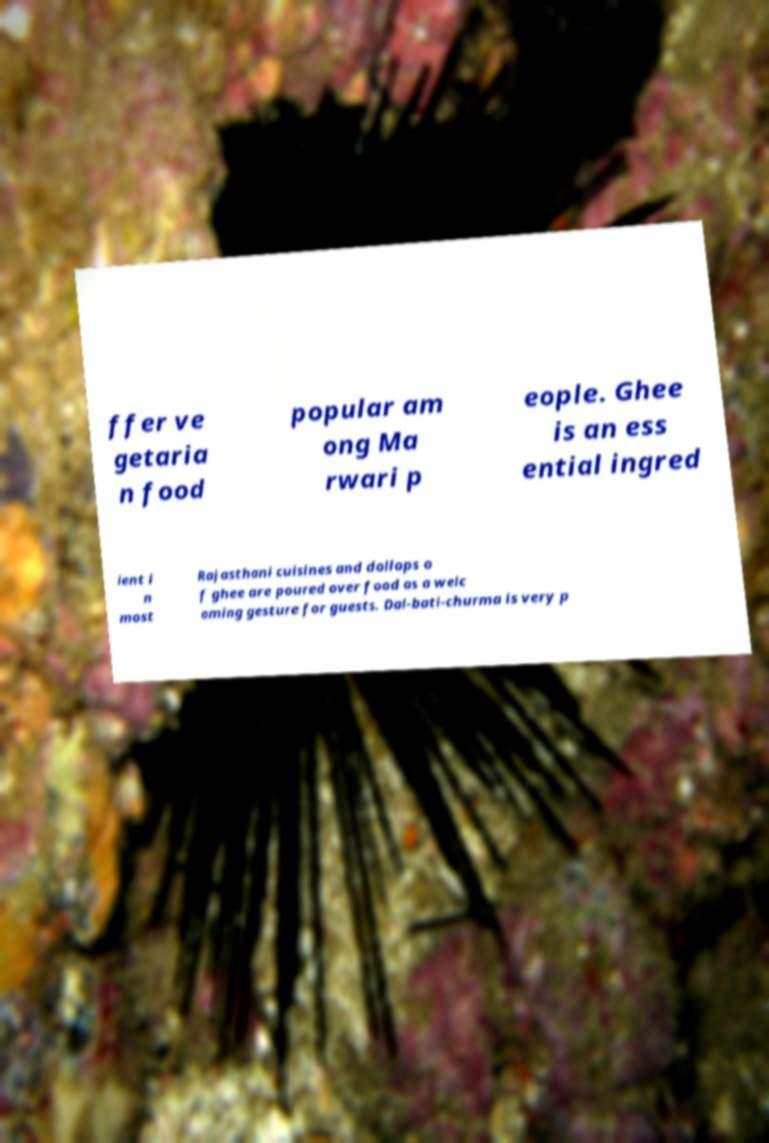Could you assist in decoding the text presented in this image and type it out clearly? ffer ve getaria n food popular am ong Ma rwari p eople. Ghee is an ess ential ingred ient i n most Rajasthani cuisines and dollops o f ghee are poured over food as a welc oming gesture for guests. Dal-bati-churma is very p 